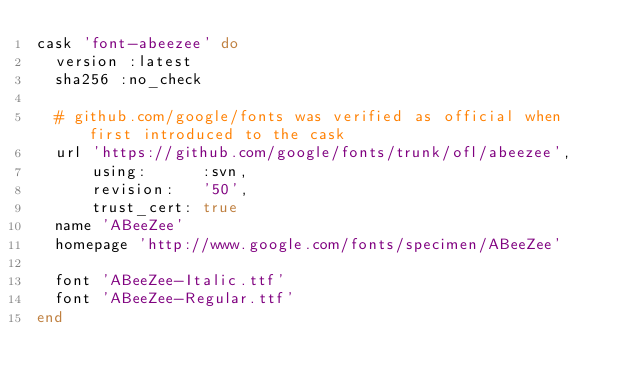Convert code to text. <code><loc_0><loc_0><loc_500><loc_500><_Ruby_>cask 'font-abeezee' do
  version :latest
  sha256 :no_check

  # github.com/google/fonts was verified as official when first introduced to the cask
  url 'https://github.com/google/fonts/trunk/ofl/abeezee',
      using:      :svn,
      revision:   '50',
      trust_cert: true
  name 'ABeeZee'
  homepage 'http://www.google.com/fonts/specimen/ABeeZee'

  font 'ABeeZee-Italic.ttf'
  font 'ABeeZee-Regular.ttf'
end
</code> 